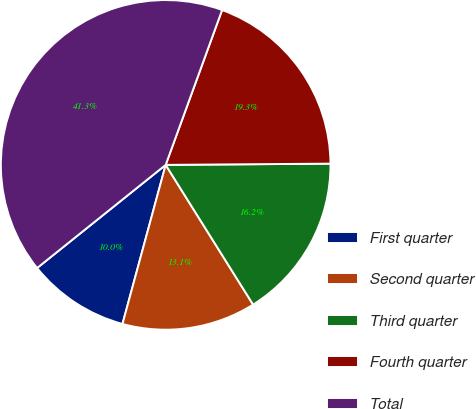Convert chart to OTSL. <chart><loc_0><loc_0><loc_500><loc_500><pie_chart><fcel>First quarter<fcel>Second quarter<fcel>Third quarter<fcel>Fourth quarter<fcel>Total<nl><fcel>10.02%<fcel>13.12%<fcel>16.22%<fcel>19.32%<fcel>41.32%<nl></chart> 